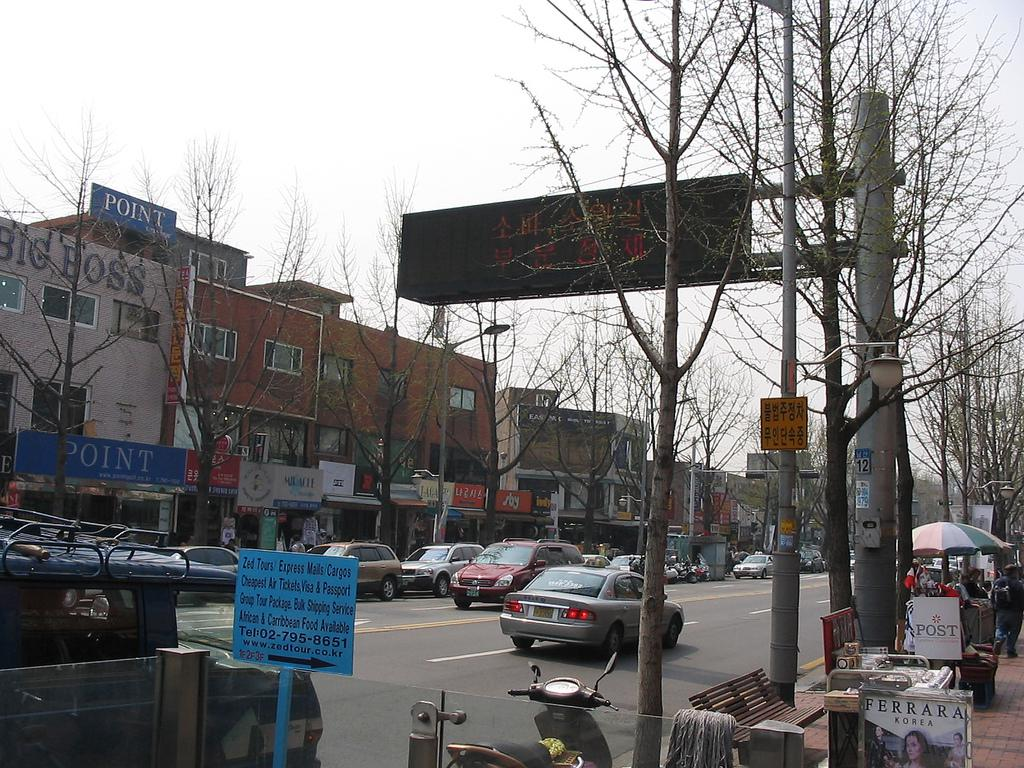Question: why are the trees bare?
Choices:
A. A storm tore them off.
B. The giraffes ate them all.
C. It is fall, or winter.
D. There was a forest fire.
Answer with the letter. Answer: C Question: what is this?
Choices:
A. Tokyo.
B. New York City.
C. A city view.
D. London.
Answer with the letter. Answer: C Question: where is the motorbike?
Choices:
A. By the curb, not far from the side.
B. In the parking space, in front of the store.
C. On the road, traveling to the next town.
D. In the showroom, with other motorbikes for sale.
Answer with the letter. Answer: A Question: who are the people in the cars that are moving in traffic?
Choices:
A. Police officers and a man they arrested.
B. A driving instructor and a teenager.
C. Drivers and passengers.
D. A woman, her daughter and her friends goint to swimming practice.
Answer with the letter. Answer: C Question: what kind of street is it?
Choices:
A. East street.
B. West street.
C. Cross street.
D. Main street.
Answer with the letter. Answer: D Question: what kind of vehicles are parked?
Choices:
A. Cars.
B. Truck.
C. Motorcycle.
D. Scooter.
Answer with the letter. Answer: A Question: what has lines painted on it?
Choices:
A. The car.
B. The road.
C. The cafe.
D. The sign.
Answer with the letter. Answer: B Question: where is an empty wooden bench?
Choices:
A. At the park.
B. At colleges.
C. On one side of the street.
D. At a courthouse.
Answer with the letter. Answer: C Question: what is attached to a gray pole?
Choices:
A. A yellow sign with symbols.
B. Parking meter.
C. American Flag.
D. Road lights.
Answer with the letter. Answer: A Question: what lines the streets?
Choices:
A. Light poles.
B. Several leafless trees.
C. Concrete slabs.
D. Garbage cans.
Answer with the letter. Answer: B 